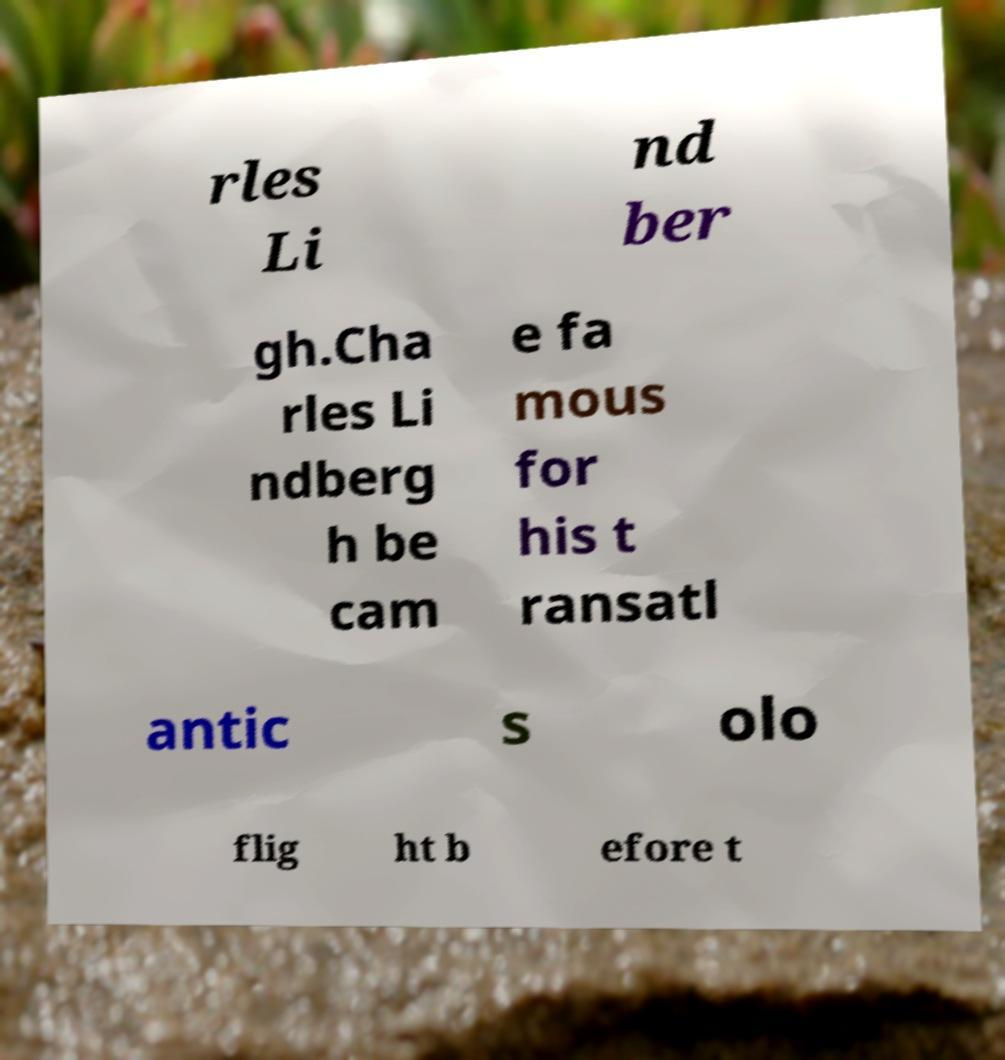What messages or text are displayed in this image? I need them in a readable, typed format. rles Li nd ber gh.Cha rles Li ndberg h be cam e fa mous for his t ransatl antic s olo flig ht b efore t 